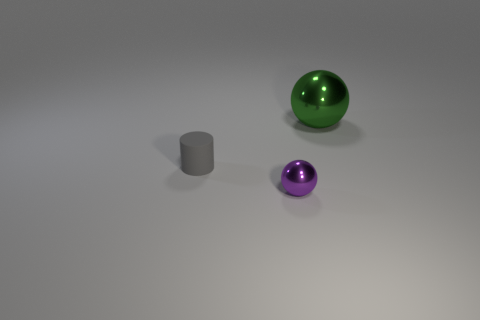What size is the purple sphere?
Provide a short and direct response. Small. Does the sphere that is in front of the green ball have the same material as the big ball?
Offer a terse response. Yes. Do the purple metal thing and the green metallic object have the same shape?
Offer a terse response. Yes. The small object behind the sphere that is to the left of the large green ball on the right side of the cylinder is what shape?
Provide a succinct answer. Cylinder. There is a small object on the right side of the gray rubber object; does it have the same shape as the thing behind the cylinder?
Provide a succinct answer. Yes. Is there another cylinder made of the same material as the cylinder?
Your response must be concise. No. The sphere behind the gray cylinder behind the tiny shiny thing in front of the tiny gray cylinder is what color?
Your response must be concise. Green. Is the thing behind the cylinder made of the same material as the tiny object behind the tiny purple ball?
Your answer should be compact. No. There is a small object that is right of the gray cylinder; what is its shape?
Make the answer very short. Sphere. How many things are either green metallic things or metallic things right of the tiny sphere?
Ensure brevity in your answer.  1. 